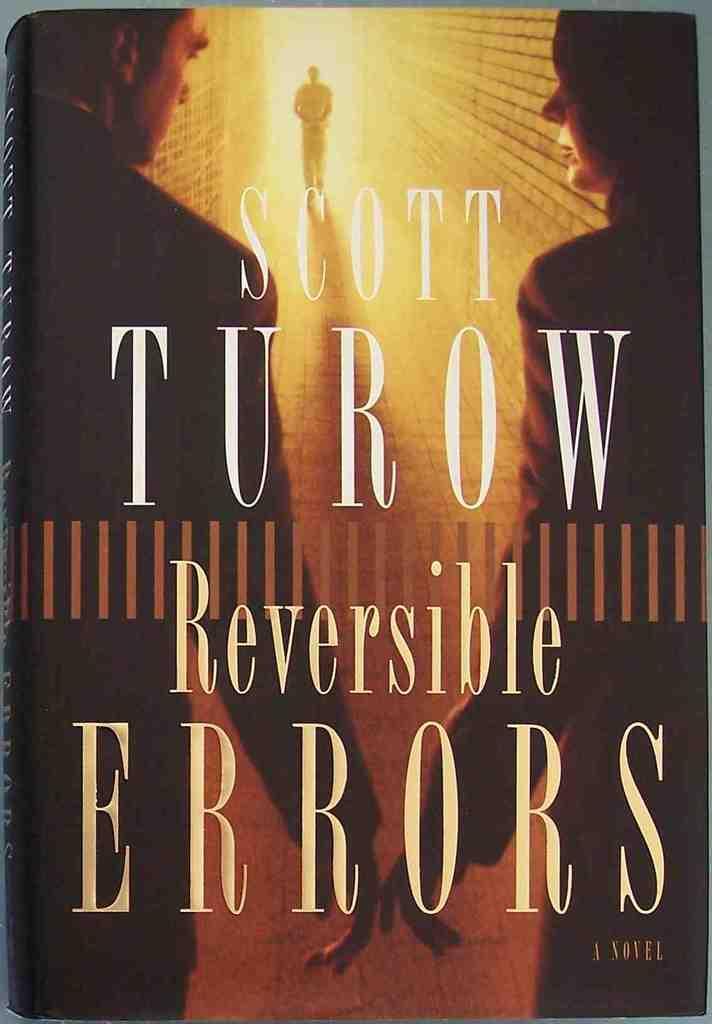Describe this image in one or two sentences. In this image we can see a cover of a book. 